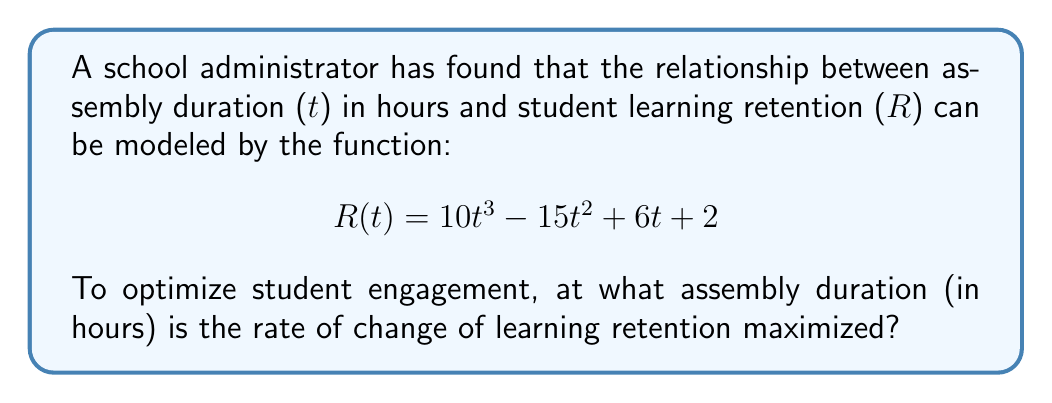Help me with this question. To find the assembly duration where the rate of change of learning retention is maximized, we need to follow these steps:

1) First, we need to find the rate of change of learning retention. This is given by the first derivative of R(t):

   $$R'(t) = 30t^2 - 30t + 6$$

2) To find where this rate of change is maximized, we need to find the maximum point of R'(t). This occurs where the derivative of R'(t) equals zero. So, we need to find the second derivative of R(t):

   $$R''(t) = 60t - 30$$

3) Set R''(t) = 0 and solve for t:

   $$60t - 30 = 0$$
   $$60t = 30$$
   $$t = \frac{1}{2} = 0.5$$

4) To confirm this is a maximum (not a minimum), we can check that R'''(t) < 0:

   $$R'''(t) = 60$$

   Since this is positive, the point we found is actually a minimum of R'(t), not a maximum.

5) Therefore, the maximum rate of change must occur at one of the endpoints of the possible domain. Since assembly duration can't be negative, we only need to consider t = 0:

   $$R'(0) = 6$$

   This is greater than the value at the critical point we found (R'(0.5) = 3.75), confirming that the maximum occurs at t = 0.
Answer: 0 hours 